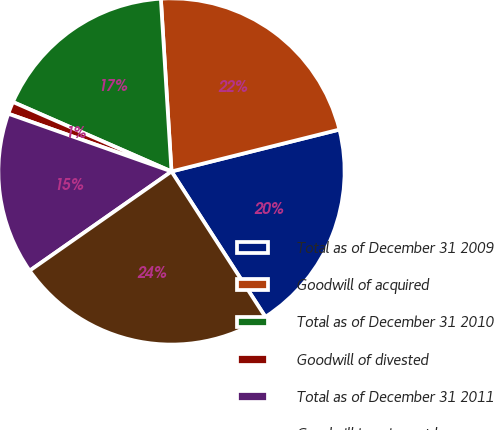Convert chart. <chart><loc_0><loc_0><loc_500><loc_500><pie_chart><fcel>Total as of December 31 2009<fcel>Goodwill of acquired<fcel>Total as of December 31 2010<fcel>Goodwill of divested<fcel>Total as of December 31 2011<fcel>Goodwill impairment loss<nl><fcel>19.77%<fcel>22.09%<fcel>17.45%<fcel>1.16%<fcel>15.13%<fcel>24.41%<nl></chart> 